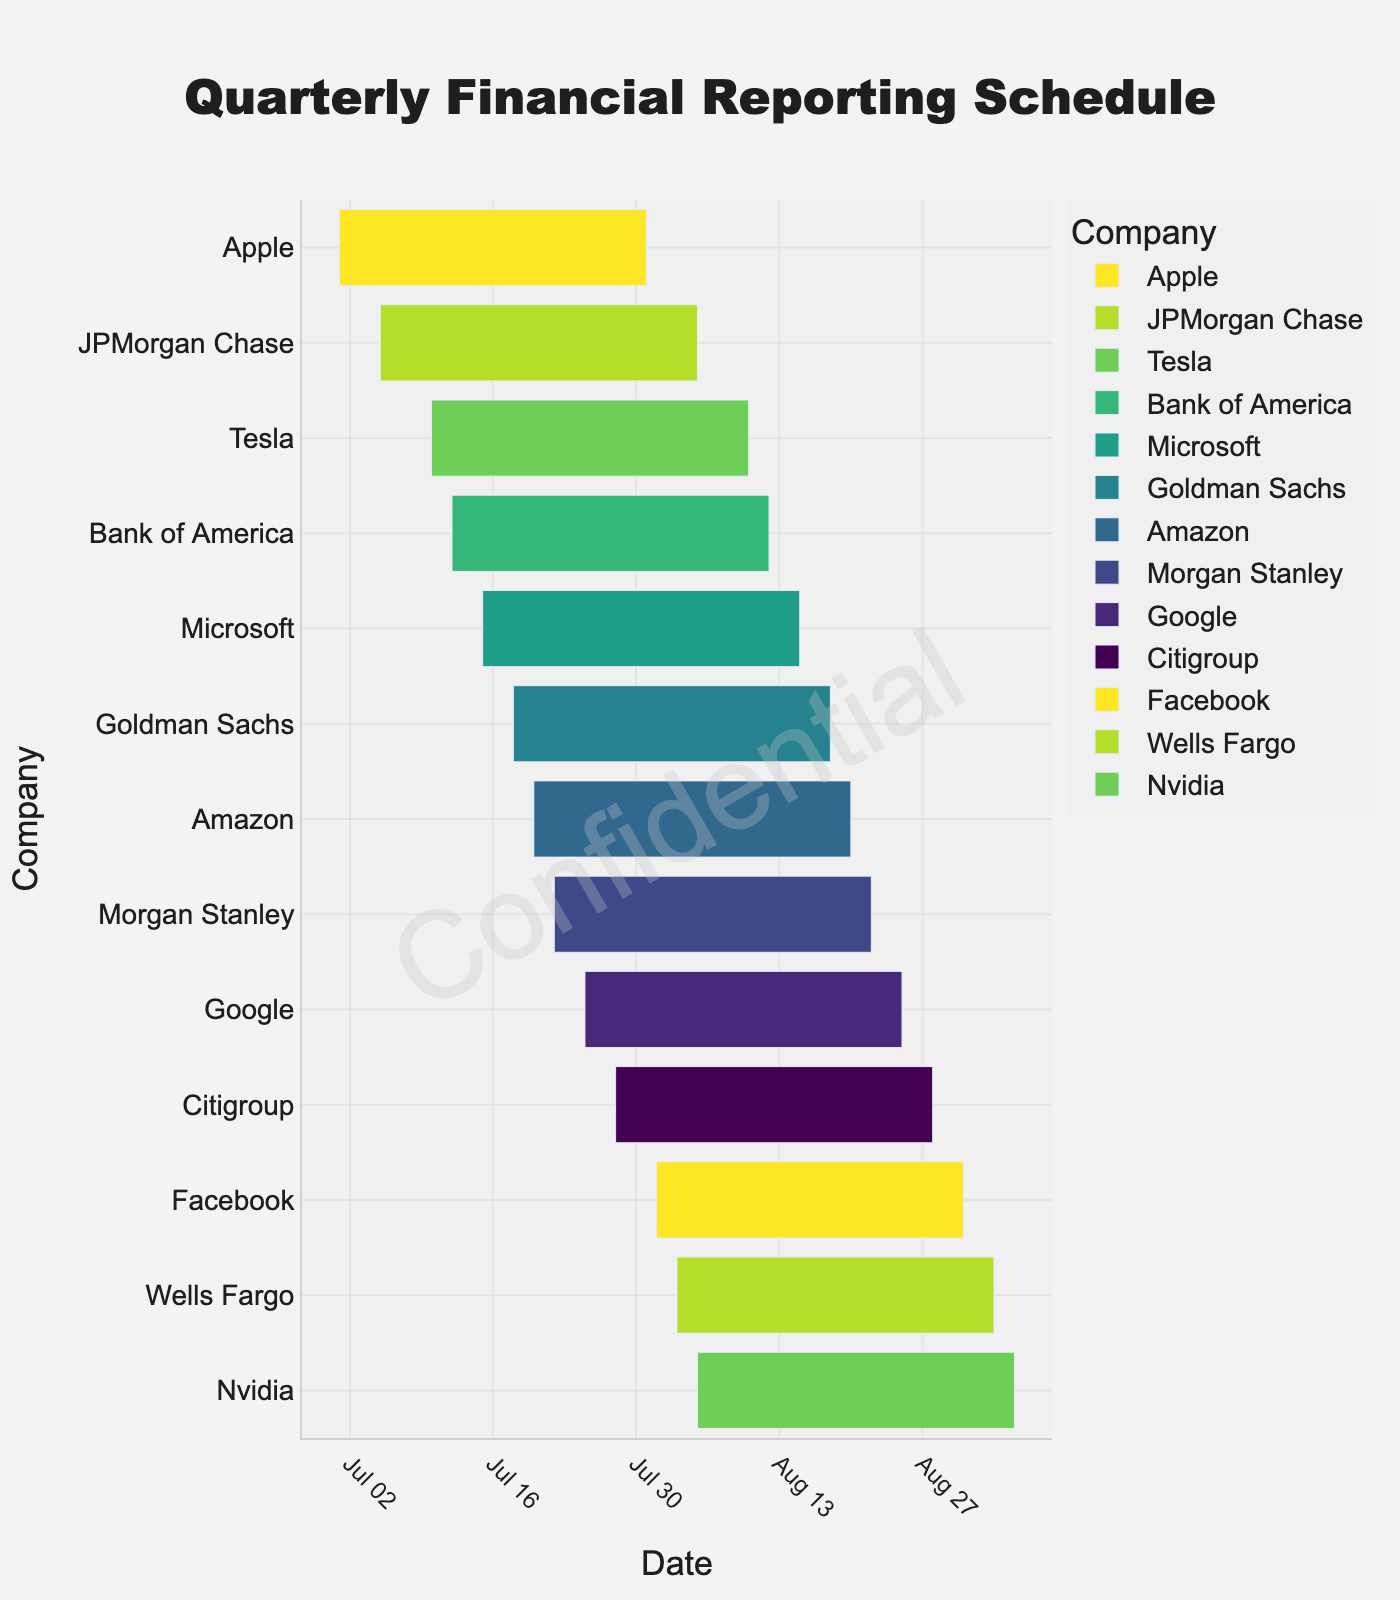What's the title of the Gantt chart? The title is located at the top center of the chart and is prominently displayed. It reads "Quarterly Financial Reporting Schedule" based on the settings in the code provided.
Answer: Quarterly Financial Reporting Schedule Which company has the earliest reporting start date, and what is that date? By looking at the chart from left to right, the company that appears first (earliest start date) is JPMorgan Chase. According to the data, its start date is 2023-07-05.
Answer: JPMorgan Chase, 2023-07-05 Which companies have reporting periods that both start and end in August 2023? By cross-referencing the start and end dates, we see that Facebook's period starts on 2023-08-01 and ends on 2023-08-31, and Nvidia's period starts on 2023-08-05 and ends on 2023-09-05. God's period also starts and ends within August 2023.
Answer: Facebook, 2023-08-01 to 2023-08-31 Which company has the longest reporting period, and how many days does it span? We calculate the span for each company by subtracting the start date from the end date. Tesla, from 2023-07-10 to 2023-08-10, spans 31 days. Google, from 2023-07-25 to 2023-08-25, spans 32 days. Thus, Google has the longest reporting period.
Answer: Google, 31 days Are there any companies whose reporting periods overlap exactly? By analyzing the dates, the reporting period for Microsoft (2023-07-15 to 2023-08-15) and Tesla (2023-07-10 to 2023-08-10) overlap. This means their reporting periods are not identical, but they do overlap.
Answer: Microsoft and Tesla Which company’s reporting period directly follows Apple’s reporting period? After Apple's reporting period ends on 2023-07-31, the next reporting period to start is Facebook, which begins on 2023-08-01.
Answer: Facebook Compare the reporting periods of Microsoft and Amazon. Which period starts first, and by how many days do they differ? Microsoft's reporting starts on 2023-07-15, and Amazon's starts on 2023-07-20. The difference is calculated as 20 - 15, equaling 5 days.
Answer: Microsoft, 5 days Identify two companies with reporting periods that fully overlap with the period of Facebook. Facebook's reporting period spans from 2023-08-01 to 2023-08-31. By checking other companies' periods, there is no company whose entire reporting period starts and ends within Facebook's period. Nvidia, starting on 2023-08-05 and ending on 2023-09-05, partially overlaps. Therefore, no companies fully overlap.
Answer: None 